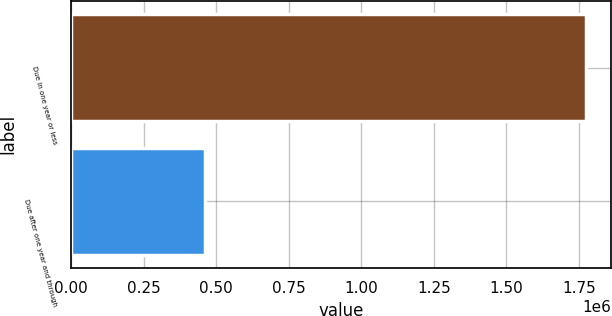<chart> <loc_0><loc_0><loc_500><loc_500><bar_chart><fcel>Due in one year or less<fcel>Due after one year and through<nl><fcel>1.77393e+06<fcel>462010<nl></chart> 